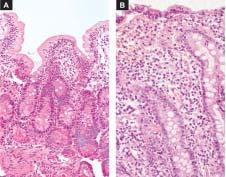s there shortening and blunting of the villi with reduction in their height?
Answer the question using a single word or phrase. Yes 